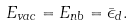<formula> <loc_0><loc_0><loc_500><loc_500>E _ { v a c } = E _ { n b } = \bar { \epsilon } _ { d } .</formula> 